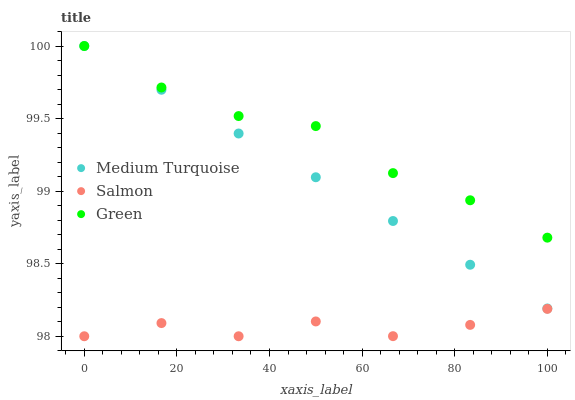Does Salmon have the minimum area under the curve?
Answer yes or no. Yes. Does Green have the maximum area under the curve?
Answer yes or no. Yes. Does Medium Turquoise have the minimum area under the curve?
Answer yes or no. No. Does Medium Turquoise have the maximum area under the curve?
Answer yes or no. No. Is Medium Turquoise the smoothest?
Answer yes or no. Yes. Is Salmon the roughest?
Answer yes or no. Yes. Is Salmon the smoothest?
Answer yes or no. No. Is Medium Turquoise the roughest?
Answer yes or no. No. Does Salmon have the lowest value?
Answer yes or no. Yes. Does Medium Turquoise have the lowest value?
Answer yes or no. No. Does Medium Turquoise have the highest value?
Answer yes or no. Yes. Does Salmon have the highest value?
Answer yes or no. No. Is Salmon less than Medium Turquoise?
Answer yes or no. Yes. Is Green greater than Salmon?
Answer yes or no. Yes. Does Green intersect Medium Turquoise?
Answer yes or no. Yes. Is Green less than Medium Turquoise?
Answer yes or no. No. Is Green greater than Medium Turquoise?
Answer yes or no. No. Does Salmon intersect Medium Turquoise?
Answer yes or no. No. 